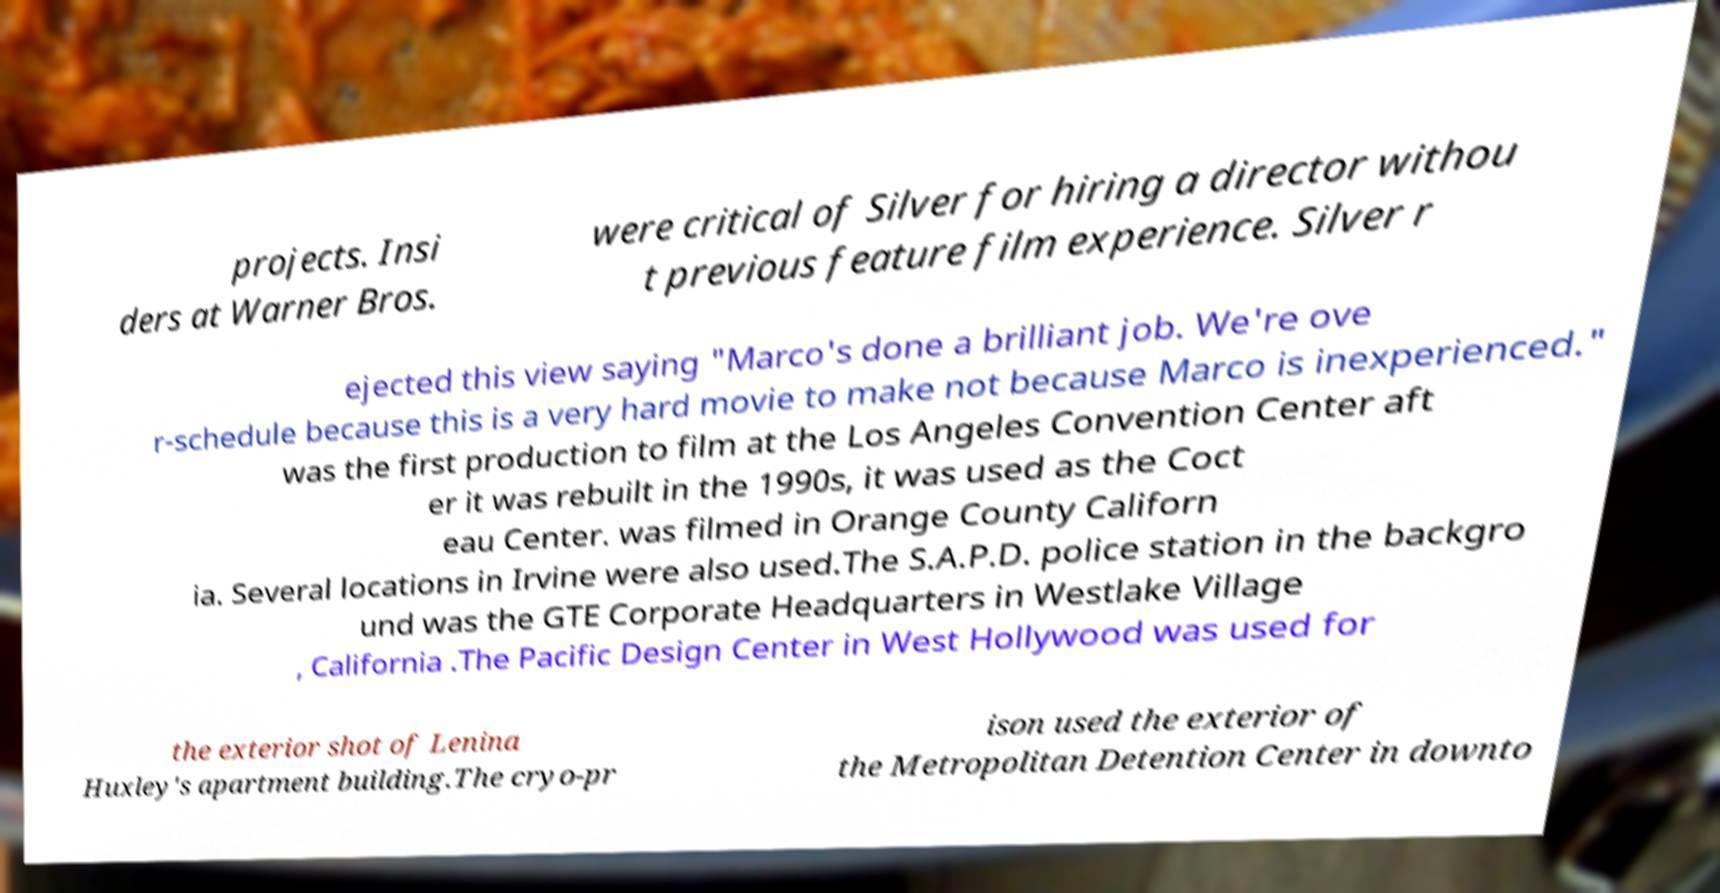I need the written content from this picture converted into text. Can you do that? projects. Insi ders at Warner Bros. were critical of Silver for hiring a director withou t previous feature film experience. Silver r ejected this view saying "Marco's done a brilliant job. We're ove r-schedule because this is a very hard movie to make not because Marco is inexperienced." was the first production to film at the Los Angeles Convention Center aft er it was rebuilt in the 1990s, it was used as the Coct eau Center. was filmed in Orange County Californ ia. Several locations in Irvine were also used.The S.A.P.D. police station in the backgro und was the GTE Corporate Headquarters in Westlake Village , California .The Pacific Design Center in West Hollywood was used for the exterior shot of Lenina Huxley's apartment building.The cryo-pr ison used the exterior of the Metropolitan Detention Center in downto 